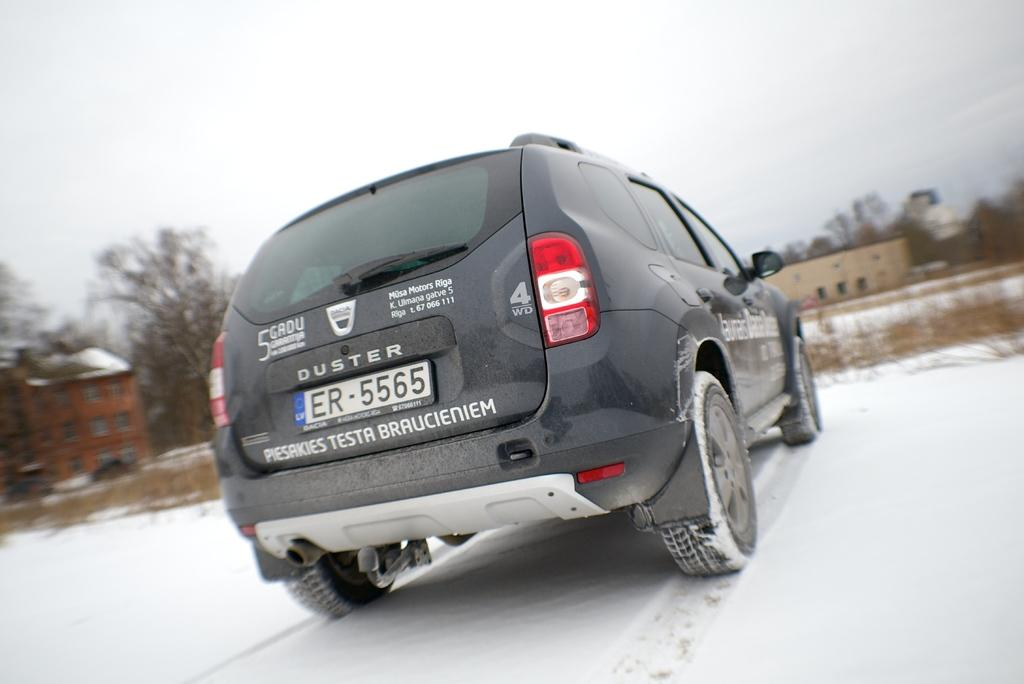What is the main subject of the image? There is a vehicle in the image. What else can be seen in the image besides the vehicle? There are buildings, windows, dry trees, dry grass, snow, and a white sky visible in the image. Can you describe the buildings in the image? The buildings in the image have windows. What is the condition of the trees and grass in the image? The trees and grass in the image are dry. What type of spy operation is being conducted in the image? There is no indication of a spy operation or any people in the image, so it cannot be determined from the image. 